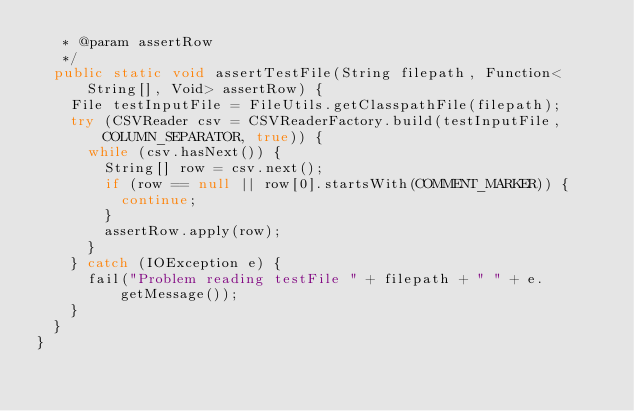<code> <loc_0><loc_0><loc_500><loc_500><_Java_>   * @param assertRow
   */
  public static void assertTestFile(String filepath, Function<String[], Void> assertRow) {
    File testInputFile = FileUtils.getClasspathFile(filepath);
    try (CSVReader csv = CSVReaderFactory.build(testInputFile, COLUMN_SEPARATOR, true)) {
      while (csv.hasNext()) {
        String[] row = csv.next();
        if (row == null || row[0].startsWith(COMMENT_MARKER)) {
          continue;
        }
        assertRow.apply(row);
      }
    } catch (IOException e) {
      fail("Problem reading testFile " + filepath + " " + e.getMessage());
    }
  }
}
</code> 